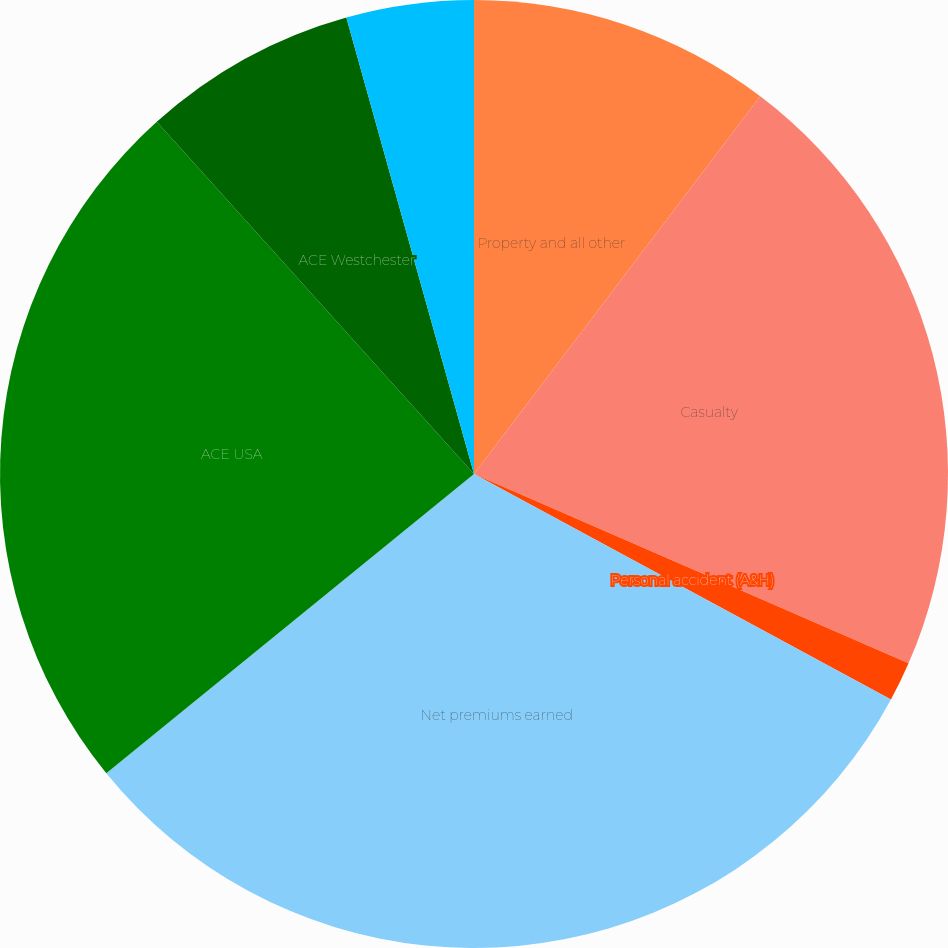<chart> <loc_0><loc_0><loc_500><loc_500><pie_chart><fcel>Property and all other<fcel>Casualty<fcel>Personal accident (A&H)<fcel>Net premiums earned<fcel>ACE USA<fcel>ACE Westchester<fcel>ACE Bermuda<nl><fcel>10.32%<fcel>21.22%<fcel>1.35%<fcel>31.24%<fcel>24.2%<fcel>7.33%<fcel>4.34%<nl></chart> 